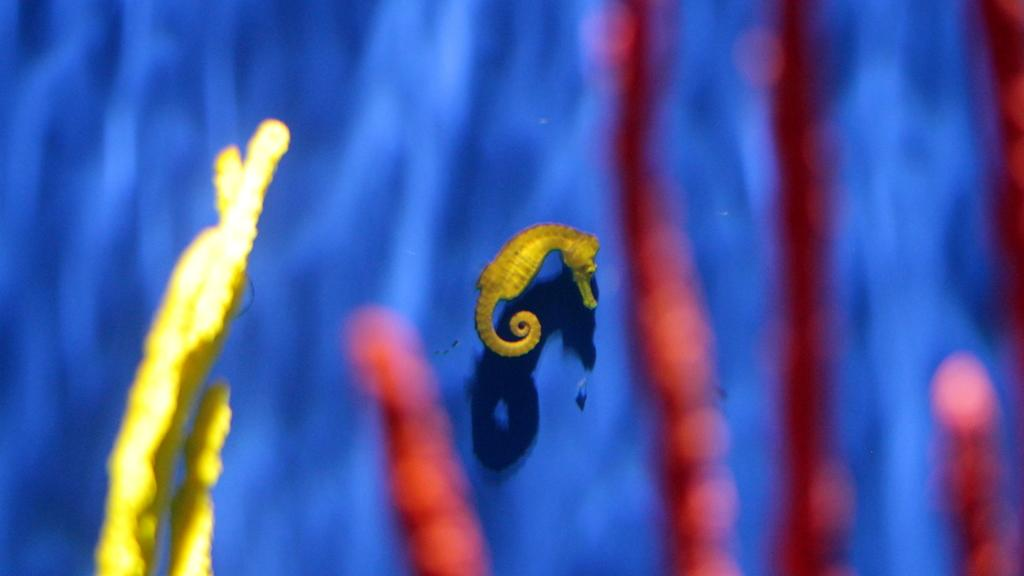What type of animal is in the image? There is a seahorse in the image. Can you describe the object near the seahorse? There is an undefined object present nearby the seahorse. How does the seahorse use its parent's magic to increase its range in the image? There is no mention of a parent or magic in the image, and the seahorse's range is not applicable in this context. 